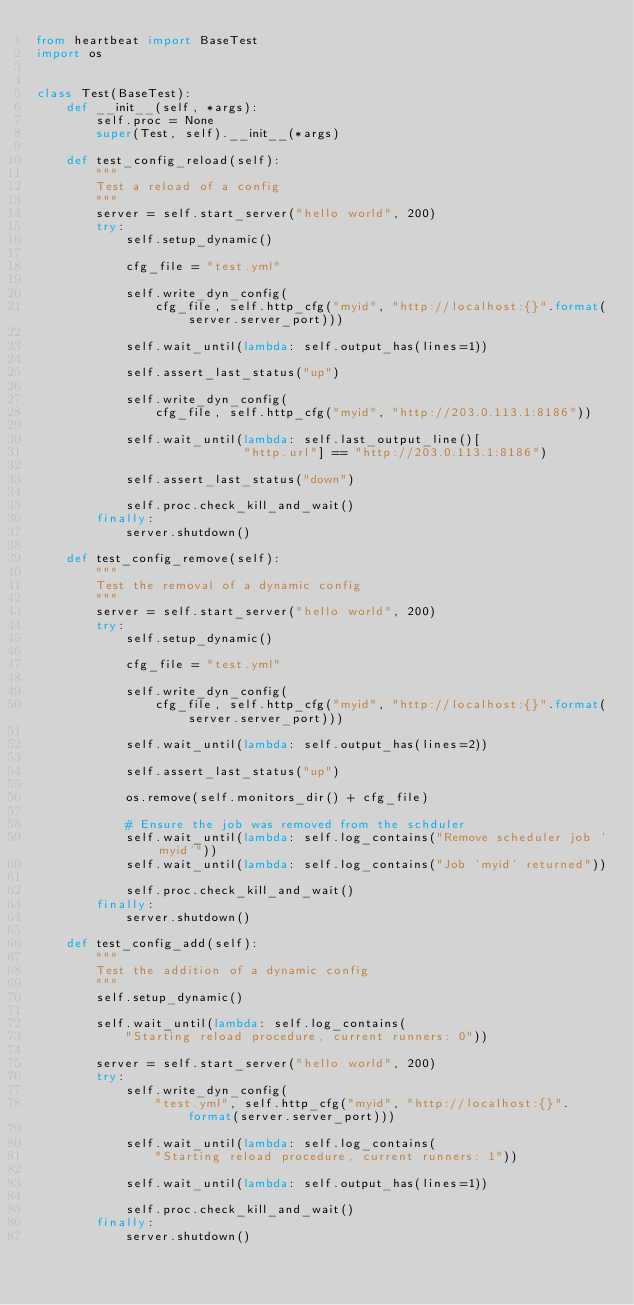Convert code to text. <code><loc_0><loc_0><loc_500><loc_500><_Python_>from heartbeat import BaseTest
import os


class Test(BaseTest):
    def __init__(self, *args):
        self.proc = None
        super(Test, self).__init__(*args)

    def test_config_reload(self):
        """
        Test a reload of a config
        """
        server = self.start_server("hello world", 200)
        try:
            self.setup_dynamic()

            cfg_file = "test.yml"

            self.write_dyn_config(
                cfg_file, self.http_cfg("myid", "http://localhost:{}".format(server.server_port)))

            self.wait_until(lambda: self.output_has(lines=1))

            self.assert_last_status("up")

            self.write_dyn_config(
                cfg_file, self.http_cfg("myid", "http://203.0.113.1:8186"))

            self.wait_until(lambda: self.last_output_line()[
                            "http.url"] == "http://203.0.113.1:8186")

            self.assert_last_status("down")

            self.proc.check_kill_and_wait()
        finally:
            server.shutdown()

    def test_config_remove(self):
        """
        Test the removal of a dynamic config
        """
        server = self.start_server("hello world", 200)
        try:
            self.setup_dynamic()

            cfg_file = "test.yml"

            self.write_dyn_config(
                cfg_file, self.http_cfg("myid", "http://localhost:{}".format(server.server_port)))

            self.wait_until(lambda: self.output_has(lines=2))

            self.assert_last_status("up")

            os.remove(self.monitors_dir() + cfg_file)

            # Ensure the job was removed from the schduler
            self.wait_until(lambda: self.log_contains("Remove scheduler job 'myid'"))
            self.wait_until(lambda: self.log_contains("Job 'myid' returned"))

            self.proc.check_kill_and_wait()
        finally:
            server.shutdown()

    def test_config_add(self):
        """
        Test the addition of a dynamic config
        """
        self.setup_dynamic()

        self.wait_until(lambda: self.log_contains(
            "Starting reload procedure, current runners: 0"))

        server = self.start_server("hello world", 200)
        try:
            self.write_dyn_config(
                "test.yml", self.http_cfg("myid", "http://localhost:{}".format(server.server_port)))

            self.wait_until(lambda: self.log_contains(
                "Starting reload procedure, current runners: 1"))

            self.wait_until(lambda: self.output_has(lines=1))

            self.proc.check_kill_and_wait()
        finally:
            server.shutdown()
</code> 